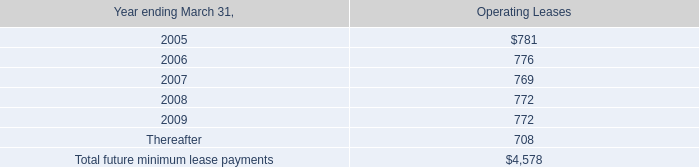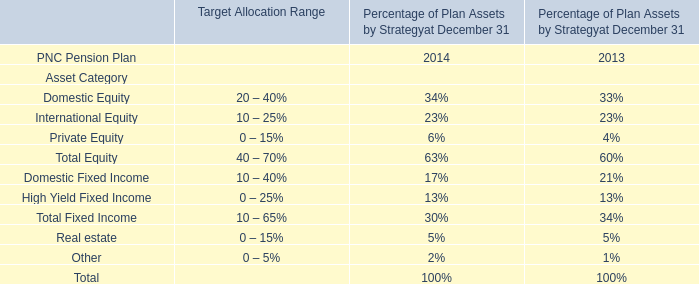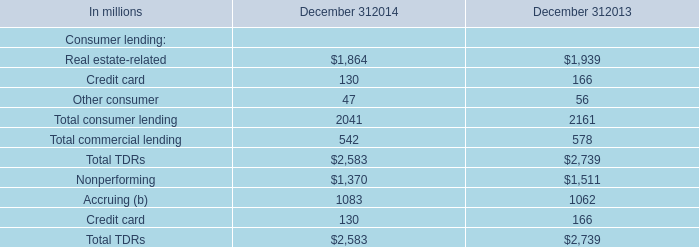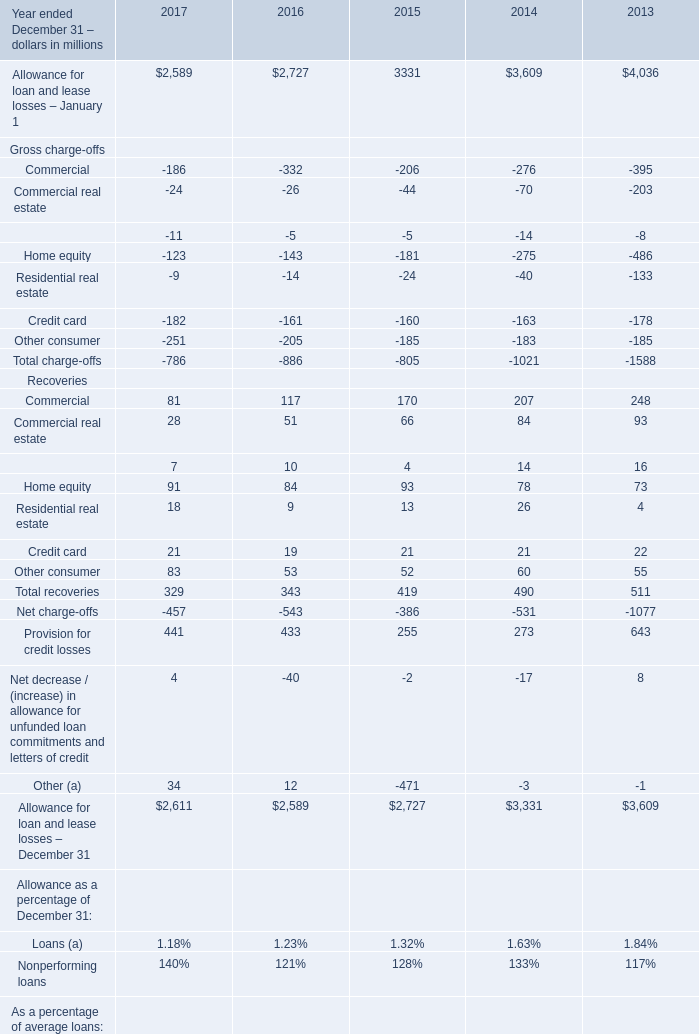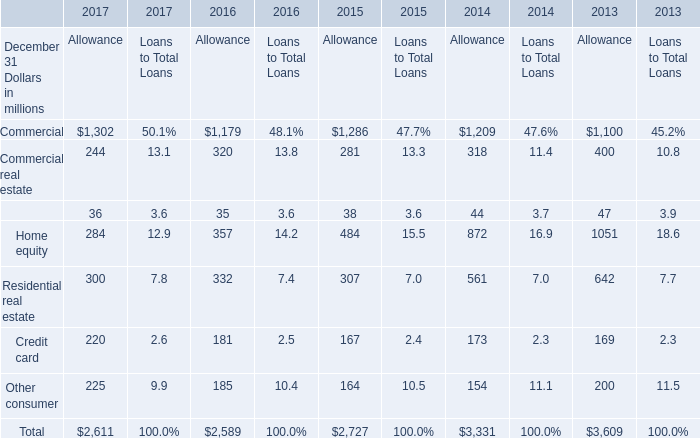What's the total value of all elements for Allowance that are smaller than 300 in 2016? (in million) 
Computations: ((35 + 181) + 185)
Answer: 401.0. 